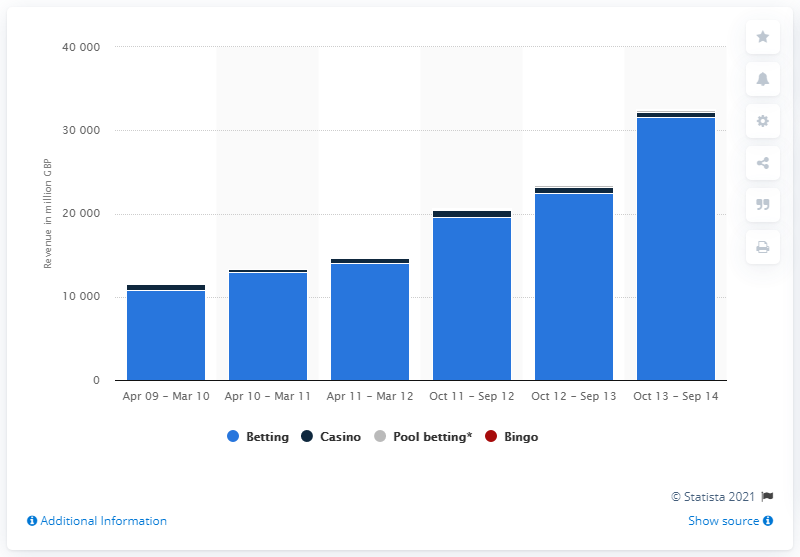Specify some key components in this picture. The revenue generated from remote sector bingo during the period of October 2011 and September 2012 was 33.78. 